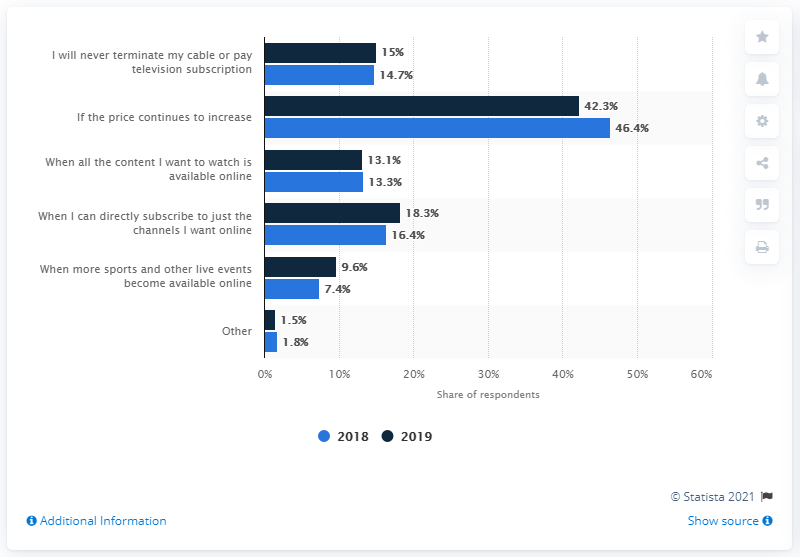Specify some key components in this picture. According to the survey, 18.3% of respondents said they would cancel their traditional cable or satellite subscription and only subscribe to the channels they want online if given the option. According to the survey, 42.3% of respondents stated that they would terminate their cable or pay television subscription if the provider continued to increase the price. 